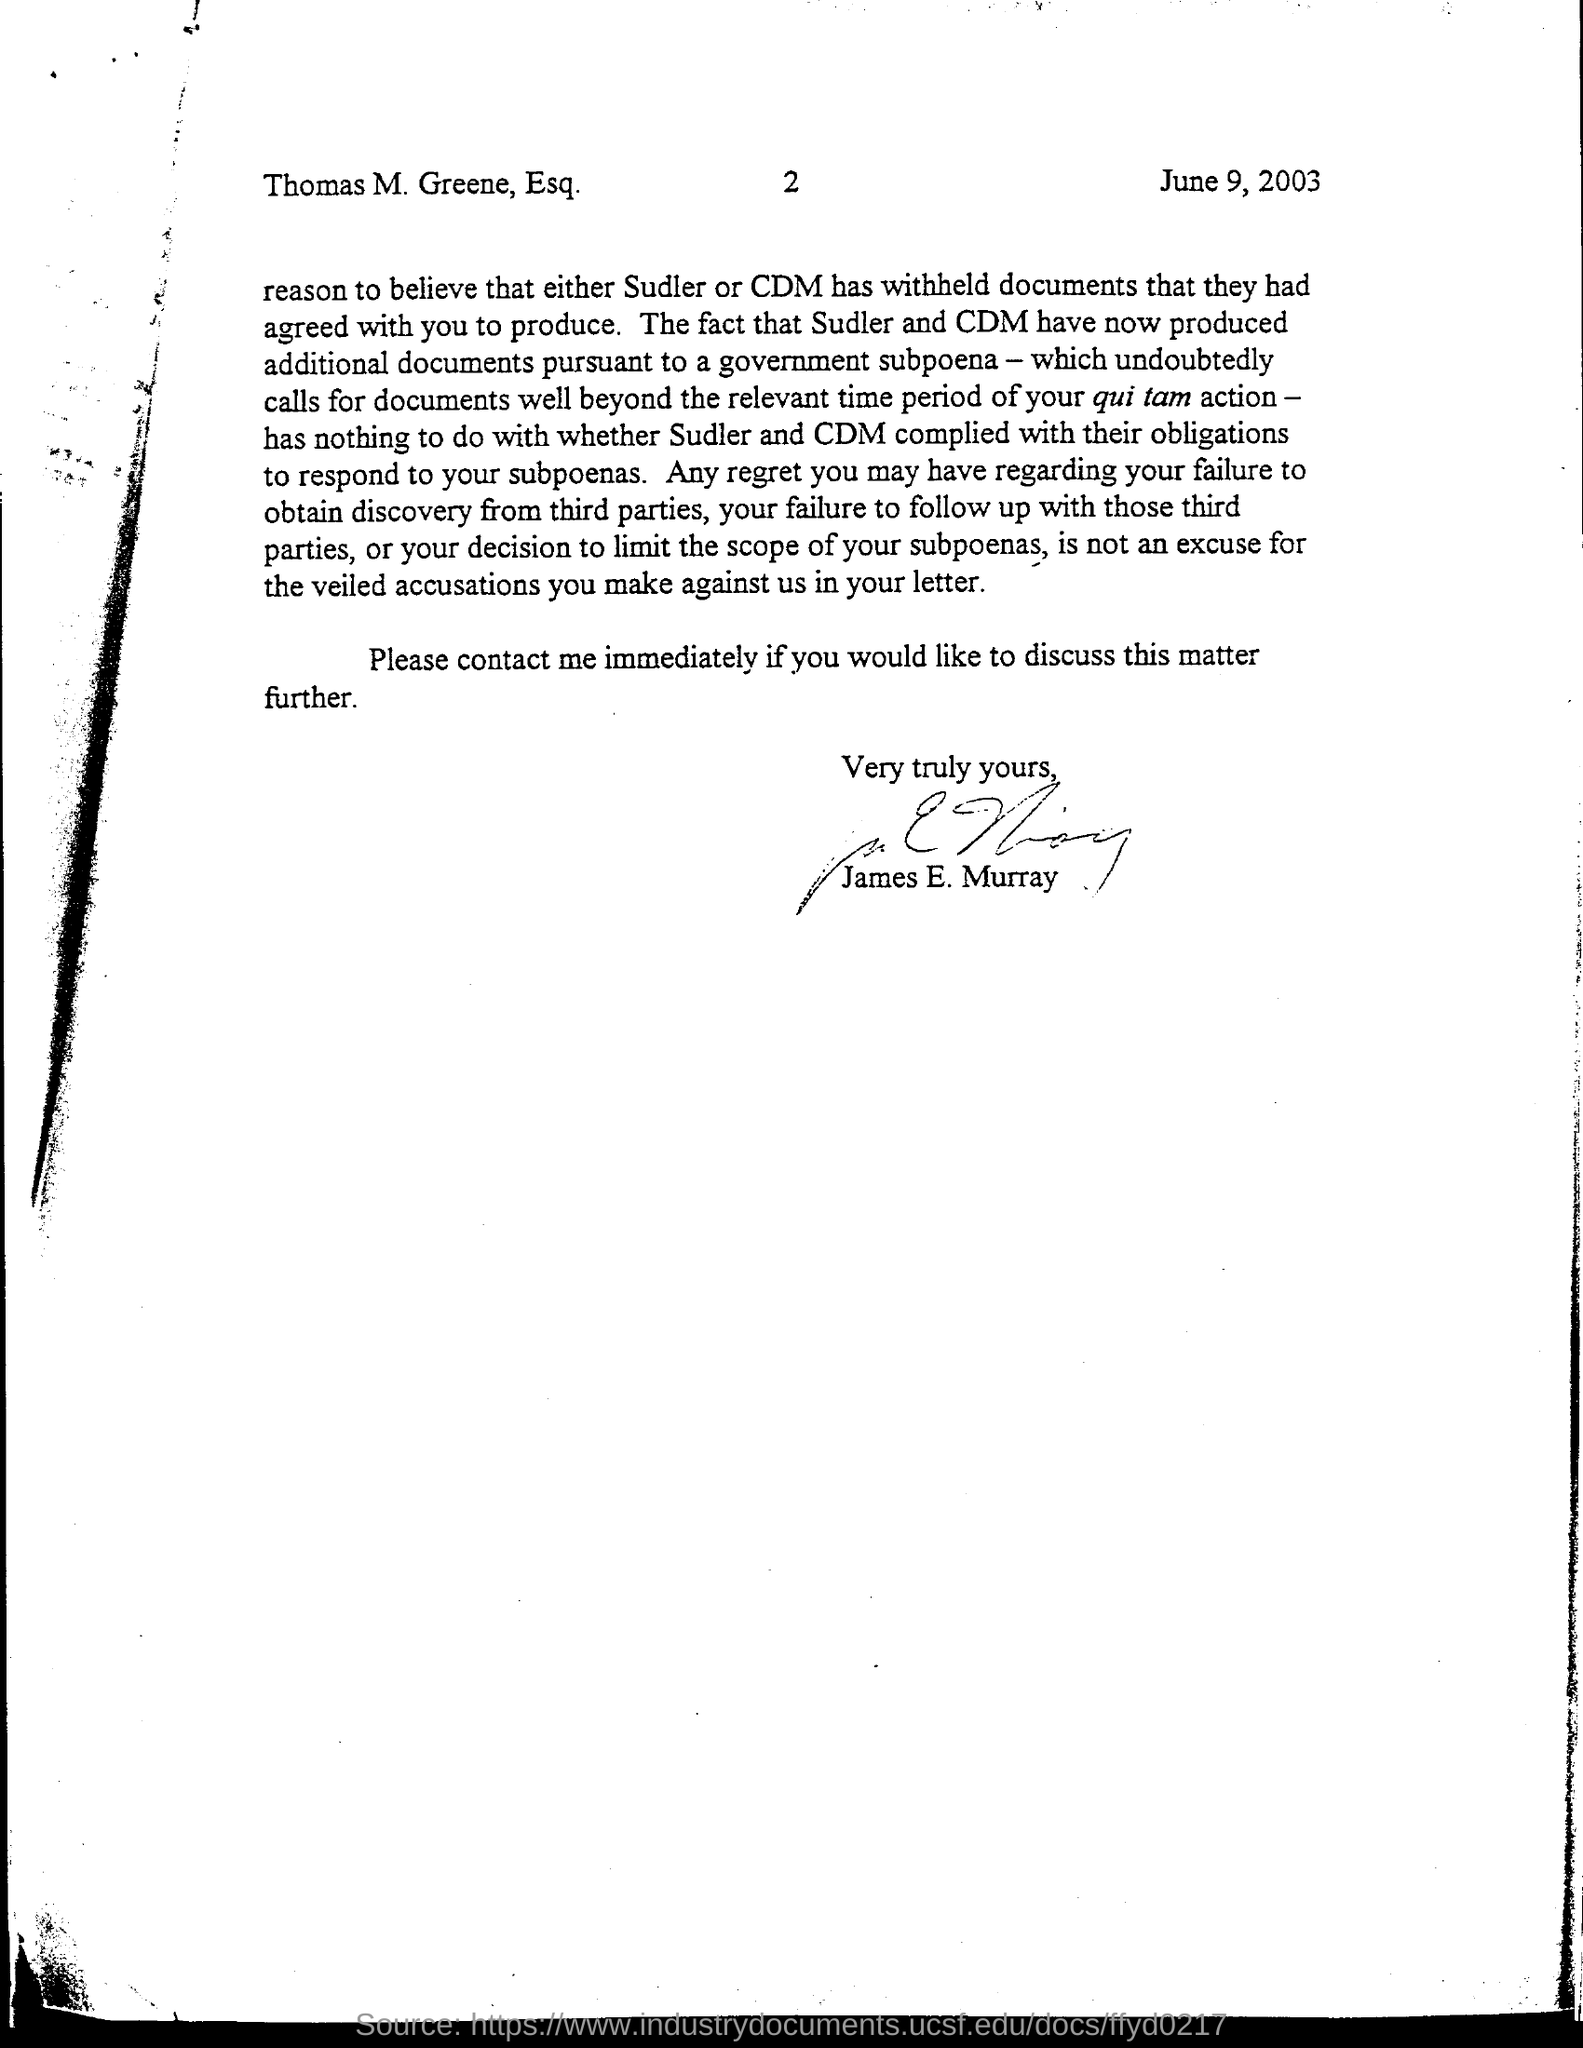Specify some key components in this picture. The page number mentioned in this document is 2. The date mentioned in this document is June 9, 2003. 